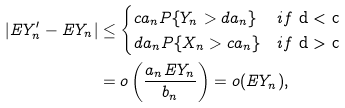Convert formula to latex. <formula><loc_0><loc_0><loc_500><loc_500>| E Y _ { n } ^ { \prime } - E Y _ { n } | & \leq \begin{cases} c a _ { n } P \{ Y _ { n } > d a _ { n } \} & i f $ d < c $ \\ d a _ { n } P \{ X _ { n } > c a _ { n } \} & i f $ d > c $ \end{cases} \\ & = o \left ( \frac { a _ { n } E Y _ { n } } { b _ { n } } \right ) = o ( E Y _ { n } ) ,</formula> 